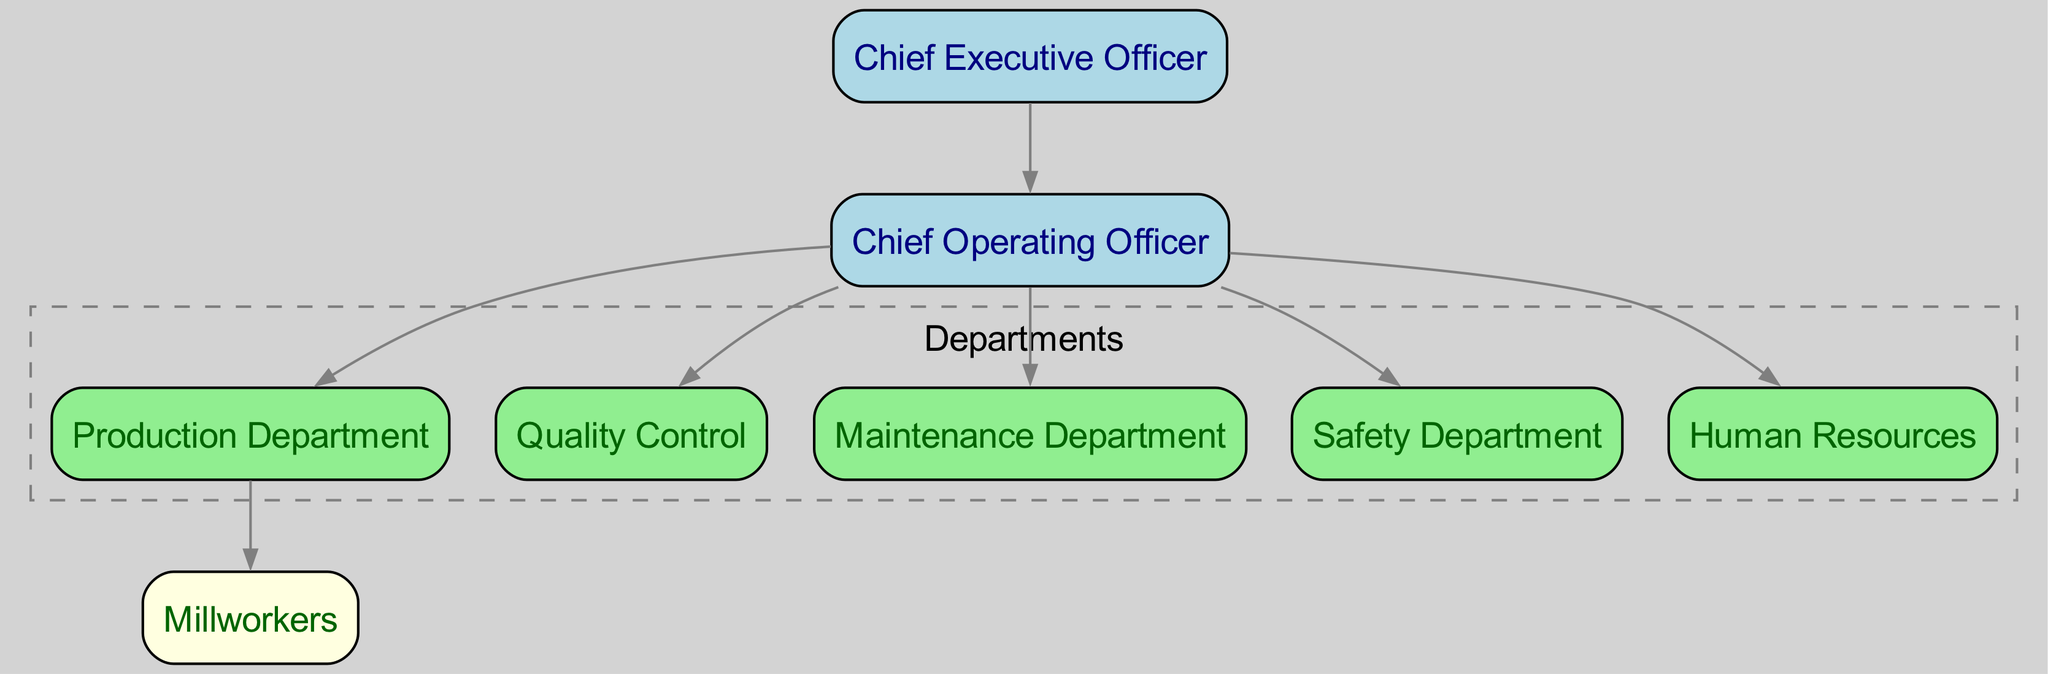What is the highest position in the organizational structure? The diagram shows the role of "Chief Executive Officer" at the top of the hierarchy, indicating it is the highest position within the organization.
Answer: Chief Executive Officer How many departments report to the Chief Operating Officer? By following the arrows from the "Chief Operating Officer," we can see there are six departments connected directly beneath it: Production, Quality Control, Maintenance, Safety, and Human Resources.
Answer: 6 Which department is responsible for millworkers? The "Production Department" has a direct line connecting to "Millworkers," indicating it is responsible for overseeing millworkers and their tasks.
Answer: Production Department What color represents the Chief Executive Officer in the diagram? The "Chief Executive Officer" node is filled with light blue color, as indicated by the coloring scheme used for the higher positions in the organizational chart.
Answer: Light blue Which department handles safety issues? The "Safety Department" is listed explicitly in the diagram, indicating that it is the designated department for managing safety within the organization.
Answer: Safety Department Who is directly above the Millworkers in the structure? The "Production Department" is directly linked above "Millworkers," showing that it manages the millworkers and their operations.
Answer: Production Department What is the role of the Human Resources department? Although the specific duties are not detailed in the diagram, the presence of "Human Resources" indicates it typically manages staffing, employee relations, and organizational training within the company.
Answer: Human Resources How many nodes are there in total? Counting all individual roles and departments in the diagram, there are eight nodes, which include the CEO, COO, and five departments plus Millworkers.
Answer: 8 What type of diagram is represented here? This diagram is structured to show the organizational hierarchy and relationships within a steel manufacturing company, specifically outlining roles and departments.
Answer: Organizational chart 